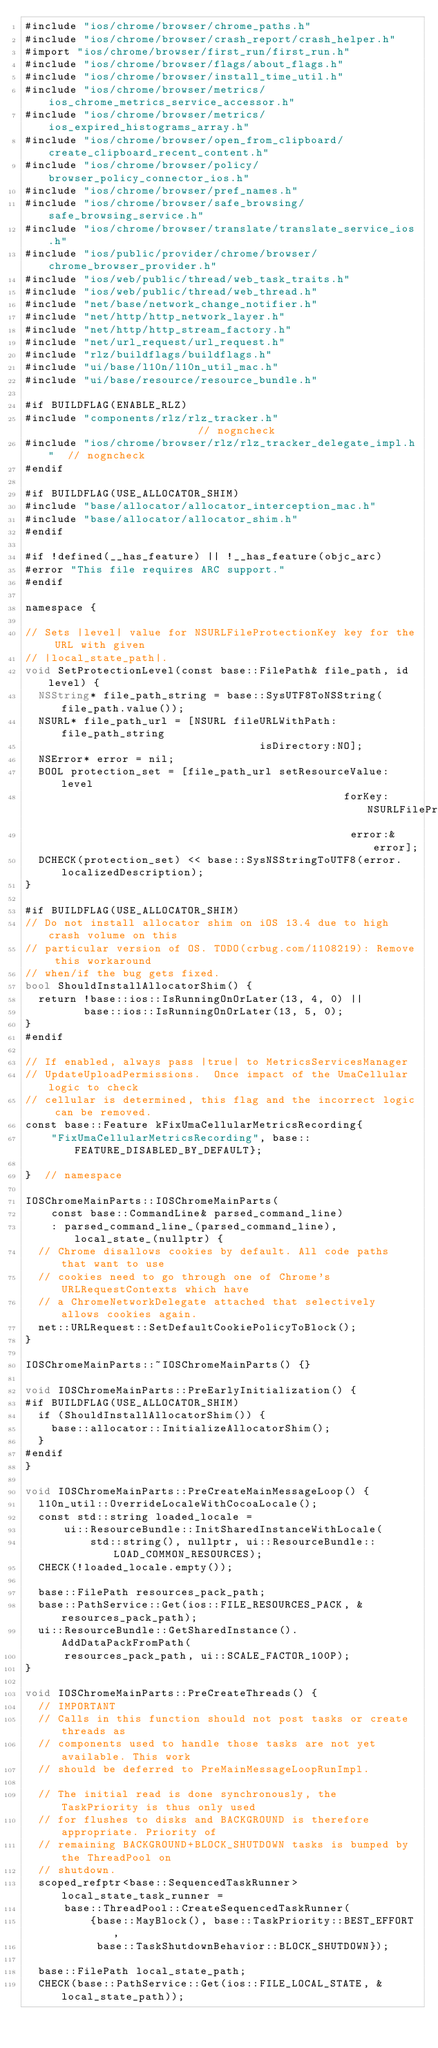<code> <loc_0><loc_0><loc_500><loc_500><_ObjectiveC_>#include "ios/chrome/browser/chrome_paths.h"
#include "ios/chrome/browser/crash_report/crash_helper.h"
#import "ios/chrome/browser/first_run/first_run.h"
#include "ios/chrome/browser/flags/about_flags.h"
#include "ios/chrome/browser/install_time_util.h"
#include "ios/chrome/browser/metrics/ios_chrome_metrics_service_accessor.h"
#include "ios/chrome/browser/metrics/ios_expired_histograms_array.h"
#include "ios/chrome/browser/open_from_clipboard/create_clipboard_recent_content.h"
#include "ios/chrome/browser/policy/browser_policy_connector_ios.h"
#include "ios/chrome/browser/pref_names.h"
#include "ios/chrome/browser/safe_browsing/safe_browsing_service.h"
#include "ios/chrome/browser/translate/translate_service_ios.h"
#include "ios/public/provider/chrome/browser/chrome_browser_provider.h"
#include "ios/web/public/thread/web_task_traits.h"
#include "ios/web/public/thread/web_thread.h"
#include "net/base/network_change_notifier.h"
#include "net/http/http_network_layer.h"
#include "net/http/http_stream_factory.h"
#include "net/url_request/url_request.h"
#include "rlz/buildflags/buildflags.h"
#include "ui/base/l10n/l10n_util_mac.h"
#include "ui/base/resource/resource_bundle.h"

#if BUILDFLAG(ENABLE_RLZ)
#include "components/rlz/rlz_tracker.h"                        // nogncheck
#include "ios/chrome/browser/rlz/rlz_tracker_delegate_impl.h"  // nogncheck
#endif

#if BUILDFLAG(USE_ALLOCATOR_SHIM)
#include "base/allocator/allocator_interception_mac.h"
#include "base/allocator/allocator_shim.h"
#endif

#if !defined(__has_feature) || !__has_feature(objc_arc)
#error "This file requires ARC support."
#endif

namespace {

// Sets |level| value for NSURLFileProtectionKey key for the URL with given
// |local_state_path|.
void SetProtectionLevel(const base::FilePath& file_path, id level) {
  NSString* file_path_string = base::SysUTF8ToNSString(file_path.value());
  NSURL* file_path_url = [NSURL fileURLWithPath:file_path_string
                                    isDirectory:NO];
  NSError* error = nil;
  BOOL protection_set = [file_path_url setResourceValue:level
                                                 forKey:NSURLFileProtectionKey
                                                  error:&error];
  DCHECK(protection_set) << base::SysNSStringToUTF8(error.localizedDescription);
}

#if BUILDFLAG(USE_ALLOCATOR_SHIM)
// Do not install allocator shim on iOS 13.4 due to high crash volume on this
// particular version of OS. TODO(crbug.com/1108219): Remove this workaround
// when/if the bug gets fixed.
bool ShouldInstallAllocatorShim() {
  return !base::ios::IsRunningOnOrLater(13, 4, 0) ||
         base::ios::IsRunningOnOrLater(13, 5, 0);
}
#endif

// If enabled, always pass |true| to MetricsServicesManager
// UpdateUploadPermissions.  Once impact of the UmaCellular logic to check
// cellular is determined, this flag and the incorrect logic can be removed.
const base::Feature kFixUmaCellularMetricsRecording{
    "FixUmaCellularMetricsRecording", base::FEATURE_DISABLED_BY_DEFAULT};

}  // namespace

IOSChromeMainParts::IOSChromeMainParts(
    const base::CommandLine& parsed_command_line)
    : parsed_command_line_(parsed_command_line), local_state_(nullptr) {
  // Chrome disallows cookies by default. All code paths that want to use
  // cookies need to go through one of Chrome's URLRequestContexts which have
  // a ChromeNetworkDelegate attached that selectively allows cookies again.
  net::URLRequest::SetDefaultCookiePolicyToBlock();
}

IOSChromeMainParts::~IOSChromeMainParts() {}

void IOSChromeMainParts::PreEarlyInitialization() {
#if BUILDFLAG(USE_ALLOCATOR_SHIM)
  if (ShouldInstallAllocatorShim()) {
    base::allocator::InitializeAllocatorShim();
  }
#endif
}

void IOSChromeMainParts::PreCreateMainMessageLoop() {
  l10n_util::OverrideLocaleWithCocoaLocale();
  const std::string loaded_locale =
      ui::ResourceBundle::InitSharedInstanceWithLocale(
          std::string(), nullptr, ui::ResourceBundle::LOAD_COMMON_RESOURCES);
  CHECK(!loaded_locale.empty());

  base::FilePath resources_pack_path;
  base::PathService::Get(ios::FILE_RESOURCES_PACK, &resources_pack_path);
  ui::ResourceBundle::GetSharedInstance().AddDataPackFromPath(
      resources_pack_path, ui::SCALE_FACTOR_100P);
}

void IOSChromeMainParts::PreCreateThreads() {
  // IMPORTANT
  // Calls in this function should not post tasks or create threads as
  // components used to handle those tasks are not yet available. This work
  // should be deferred to PreMainMessageLoopRunImpl.

  // The initial read is done synchronously, the TaskPriority is thus only used
  // for flushes to disks and BACKGROUND is therefore appropriate. Priority of
  // remaining BACKGROUND+BLOCK_SHUTDOWN tasks is bumped by the ThreadPool on
  // shutdown.
  scoped_refptr<base::SequencedTaskRunner> local_state_task_runner =
      base::ThreadPool::CreateSequencedTaskRunner(
          {base::MayBlock(), base::TaskPriority::BEST_EFFORT,
           base::TaskShutdownBehavior::BLOCK_SHUTDOWN});

  base::FilePath local_state_path;
  CHECK(base::PathService::Get(ios::FILE_LOCAL_STATE, &local_state_path));</code> 